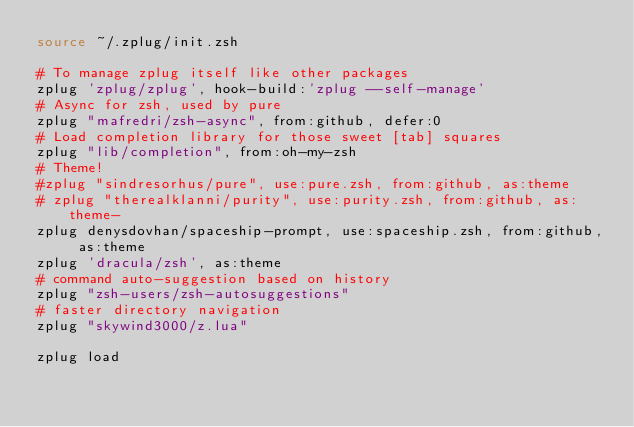<code> <loc_0><loc_0><loc_500><loc_500><_Bash_>source ~/.zplug/init.zsh

# To manage zplug itself like other packages
zplug 'zplug/zplug', hook-build:'zplug --self-manage'
# Async for zsh, used by pure
zplug "mafredri/zsh-async", from:github, defer:0
# Load completion library for those sweet [tab] squares
zplug "lib/completion", from:oh-my-zsh
# Theme!
#zplug "sindresorhus/pure", use:pure.zsh, from:github, as:theme
# zplug "therealklanni/purity", use:purity.zsh, from:github, as:theme-
zplug denysdovhan/spaceship-prompt, use:spaceship.zsh, from:github, as:theme
zplug 'dracula/zsh', as:theme
# command auto-suggestion based on history
zplug "zsh-users/zsh-autosuggestions"
# faster directory navigation
zplug "skywind3000/z.lua"

zplug load
</code> 